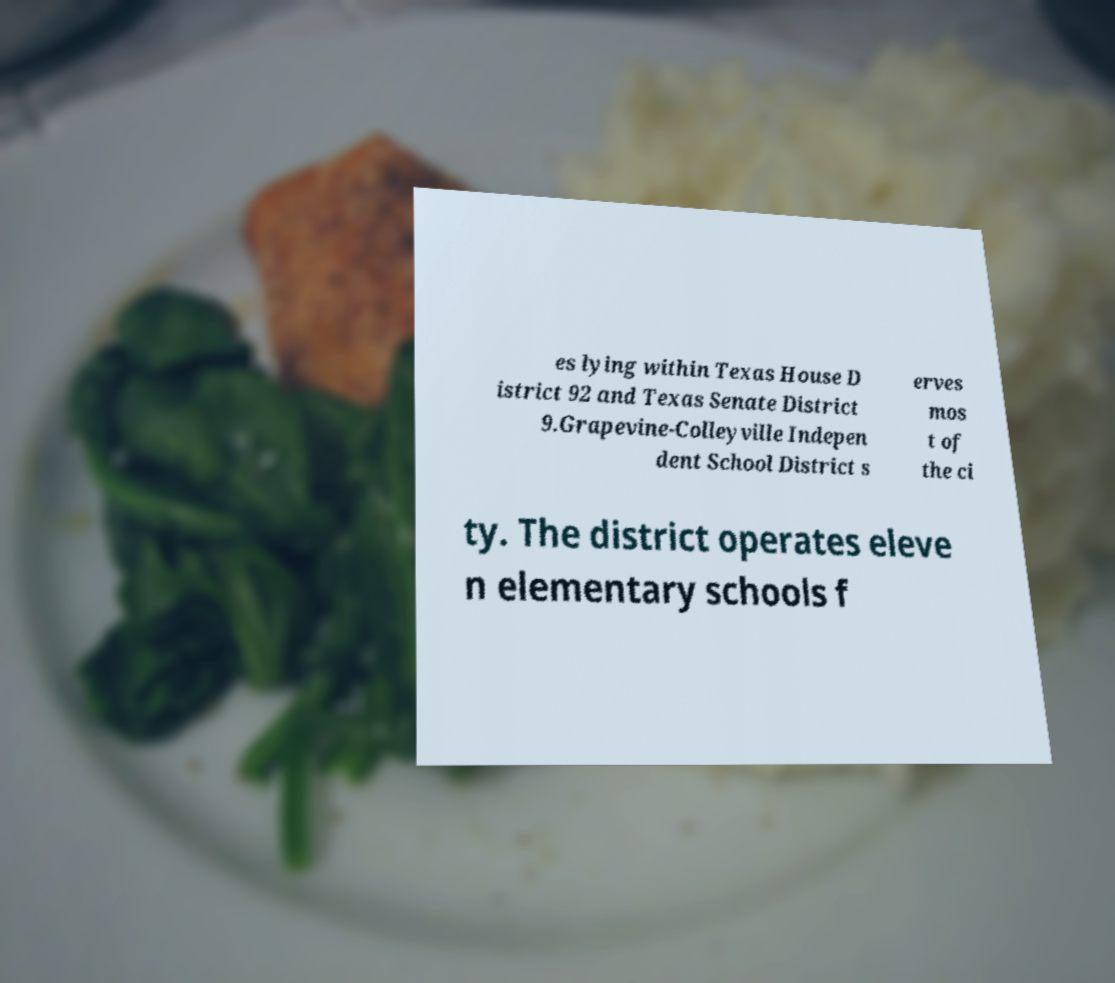Please read and relay the text visible in this image. What does it say? es lying within Texas House D istrict 92 and Texas Senate District 9.Grapevine-Colleyville Indepen dent School District s erves mos t of the ci ty. The district operates eleve n elementary schools f 